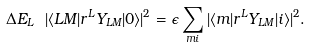<formula> <loc_0><loc_0><loc_500><loc_500>\Delta E _ { L } \ | \langle L M | r ^ { L } Y _ { L M } | 0 \rangle | ^ { 2 } = \epsilon \sum _ { m i } | \langle m | r ^ { L } Y _ { L M } | i \rangle | ^ { 2 } .</formula> 